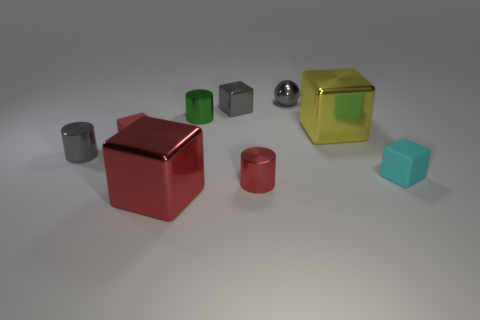Subtract all red metal blocks. How many blocks are left? 4 Subtract all red blocks. How many blocks are left? 3 Subtract all purple cubes. Subtract all yellow cylinders. How many cubes are left? 5 Add 1 shiny balls. How many objects exist? 10 Subtract all cubes. How many objects are left? 4 Add 5 small red things. How many small red things exist? 7 Subtract 1 green cylinders. How many objects are left? 8 Subtract all small yellow rubber objects. Subtract all gray metallic balls. How many objects are left? 8 Add 6 big objects. How many big objects are left? 8 